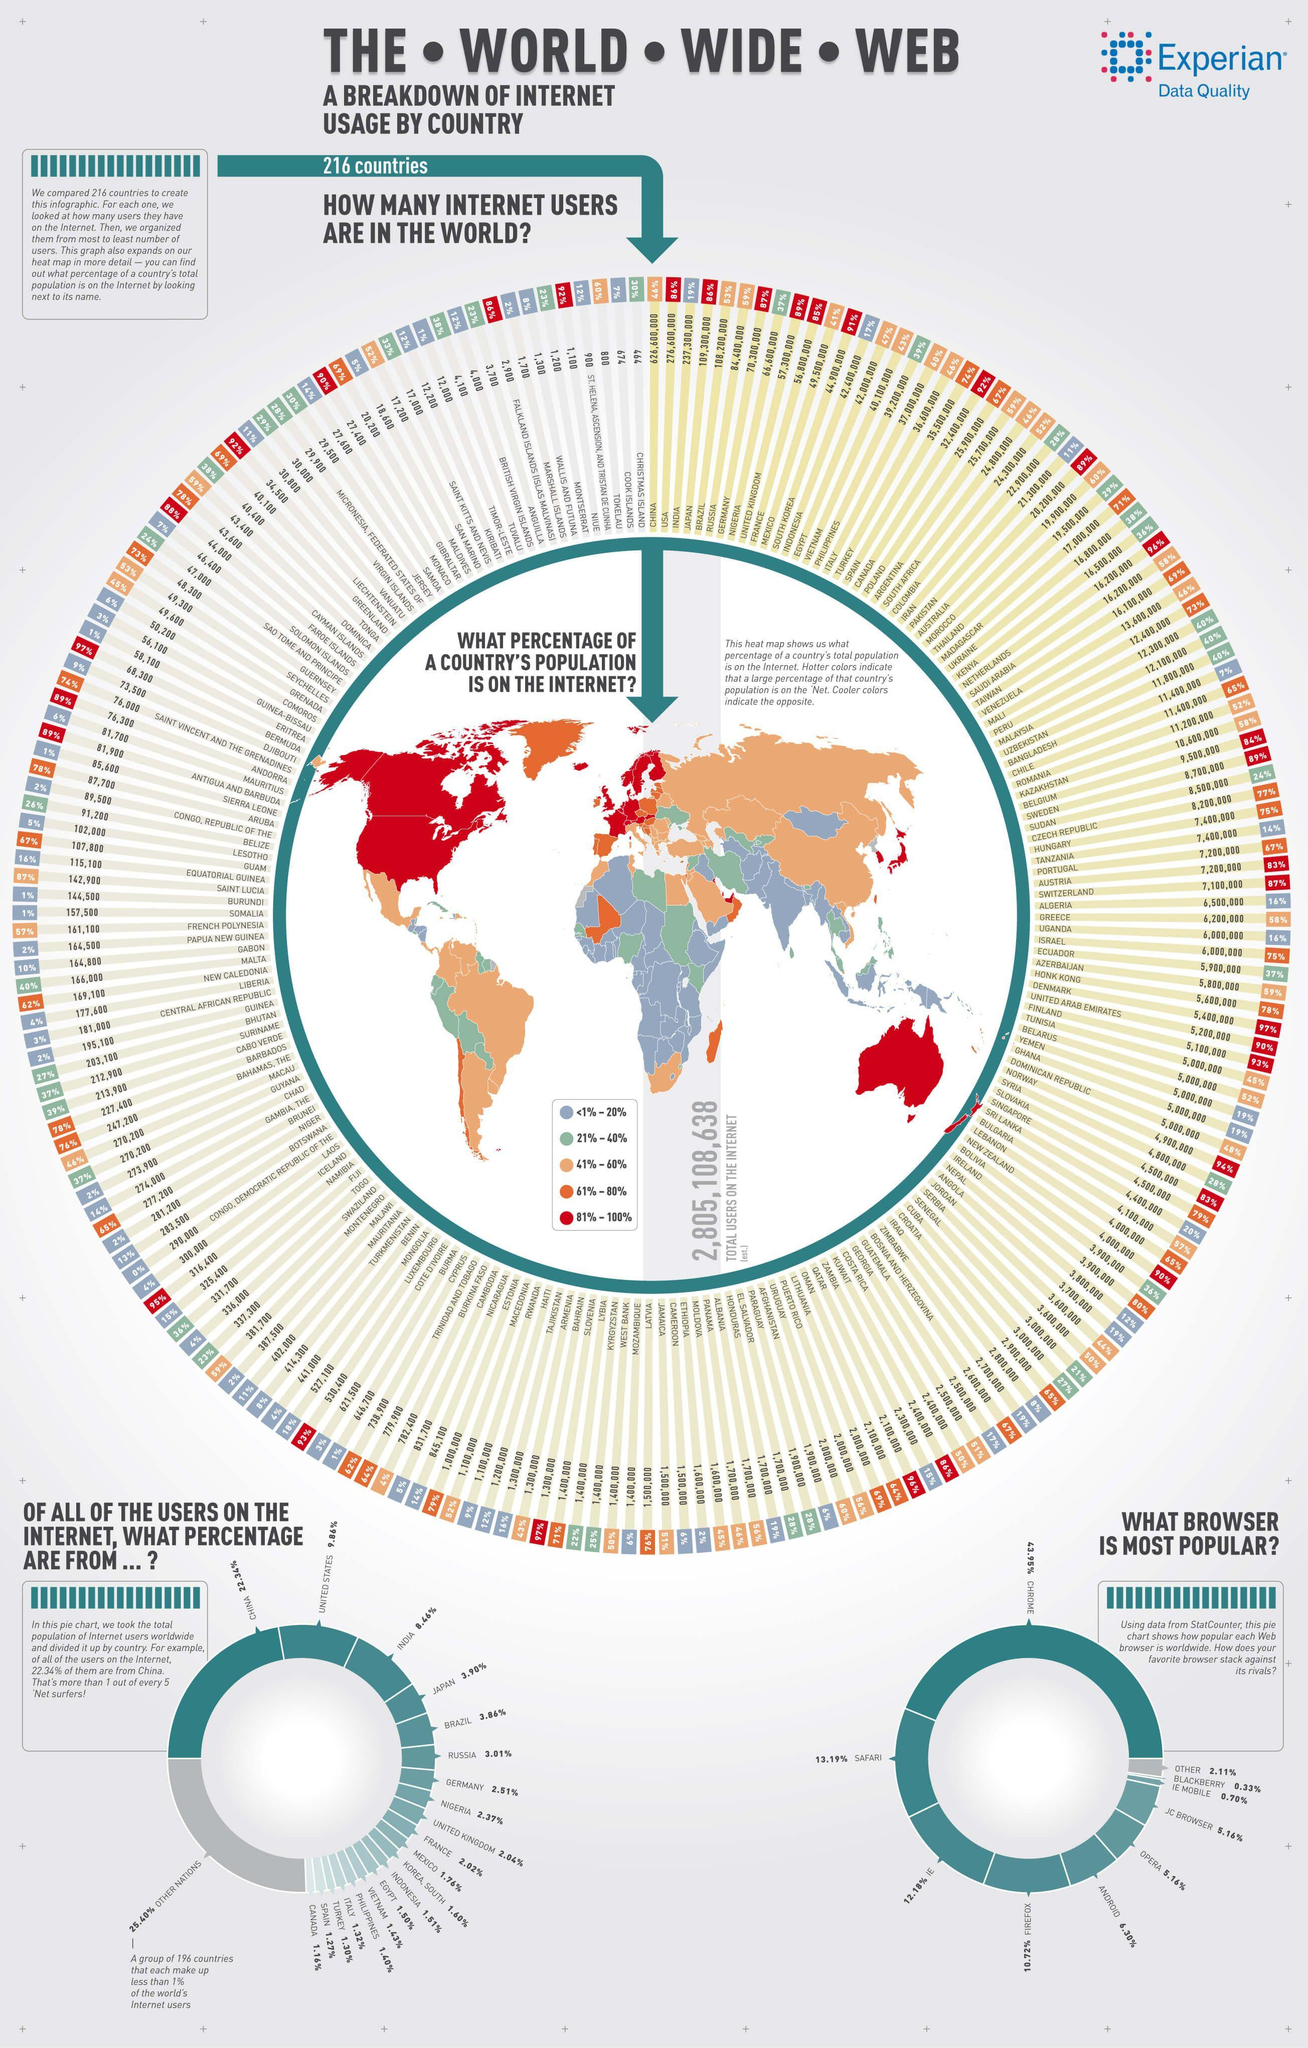Point out several critical features in this image. Kenya and the Netherlands are the two countries that have a total of 16,200,000 internet users. According to a recent survey, 89% of the population in the United Kingdom uses the internet. According to a recent estimate, only 27% of the population in Bhutan are internet users. Christmas Island has the least amount of Internet users among all countries. There are approximately 20 countries that make up more than 1% of internet users in the world. 